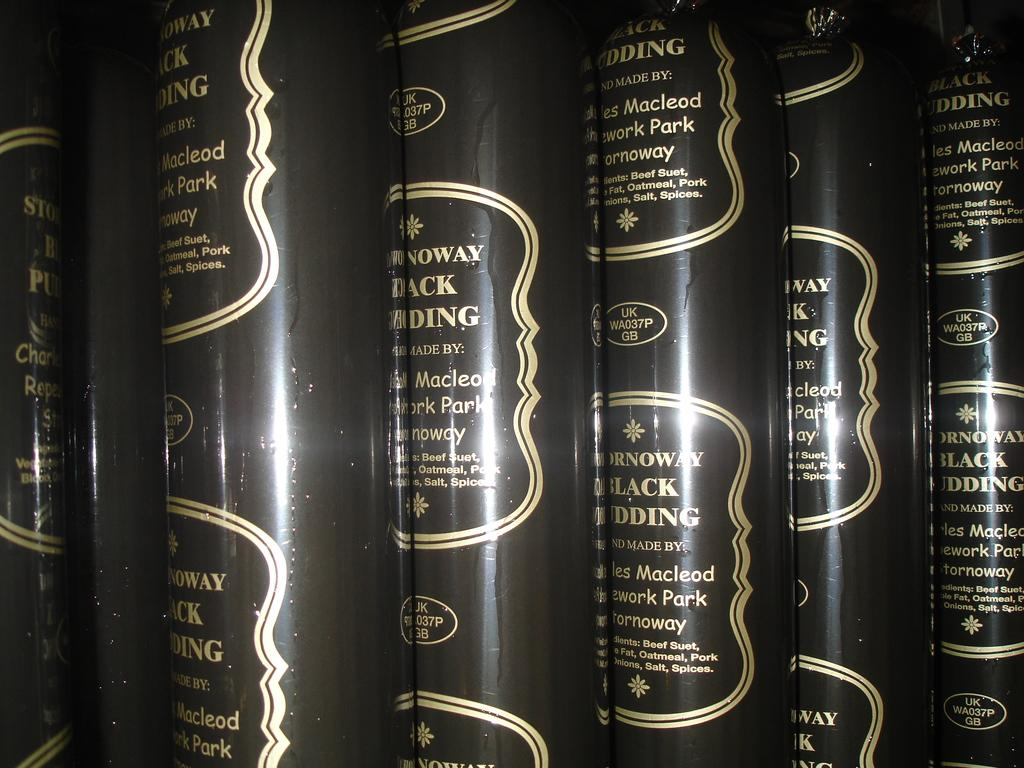<image>
Share a concise interpretation of the image provided. Many containers of black pudding are shown, and it contains beef suet. 